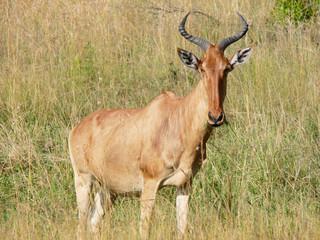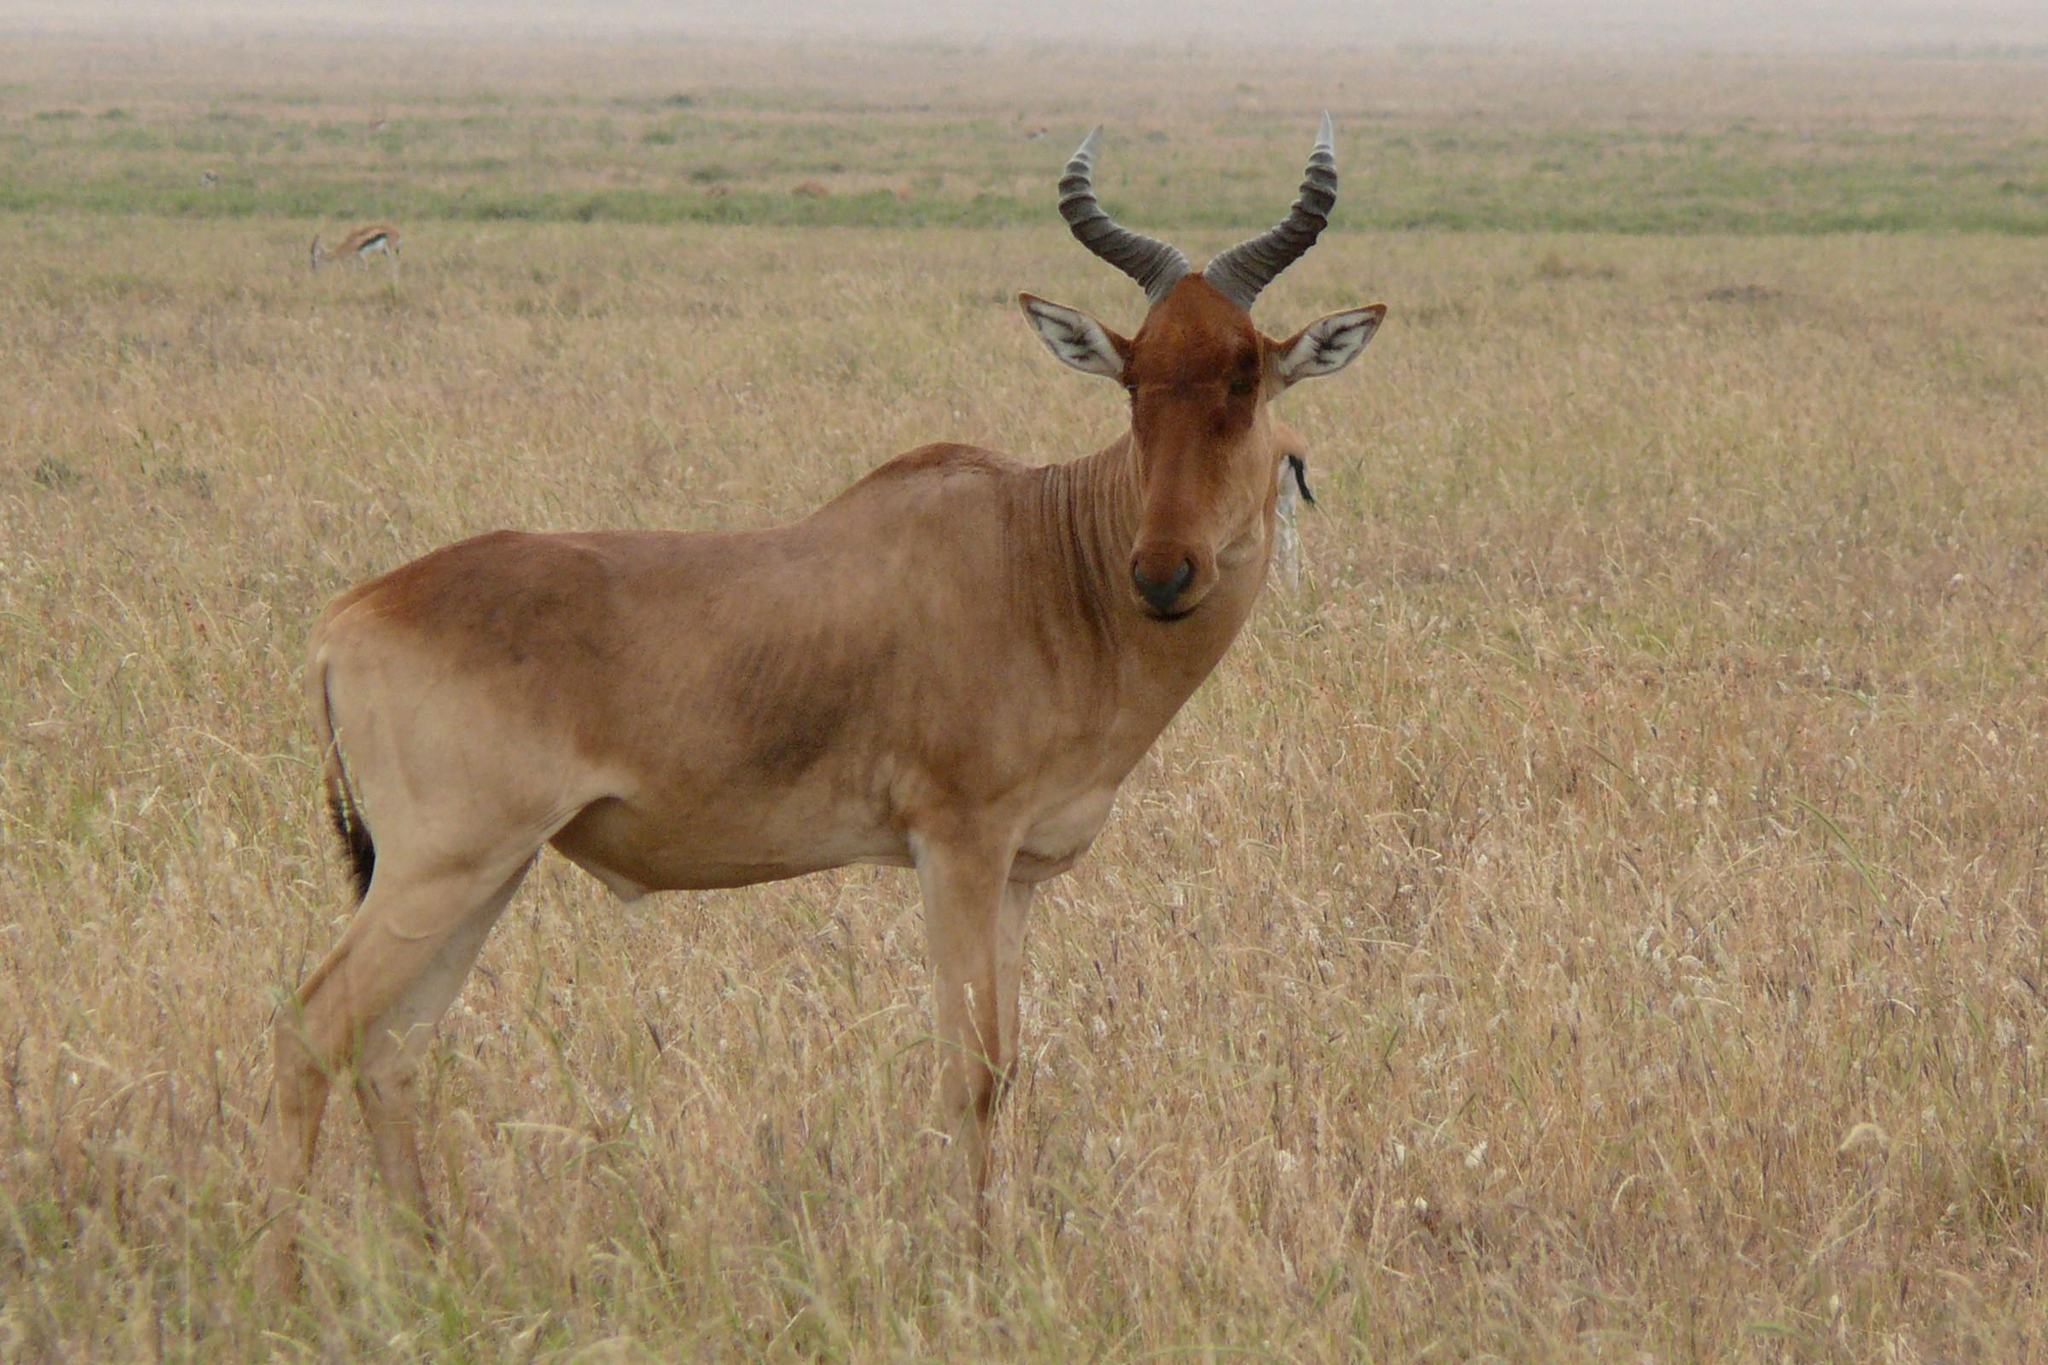The first image is the image on the left, the second image is the image on the right. Given the left and right images, does the statement "Both images feature animals facing the same direction." hold true? Answer yes or no. Yes. 